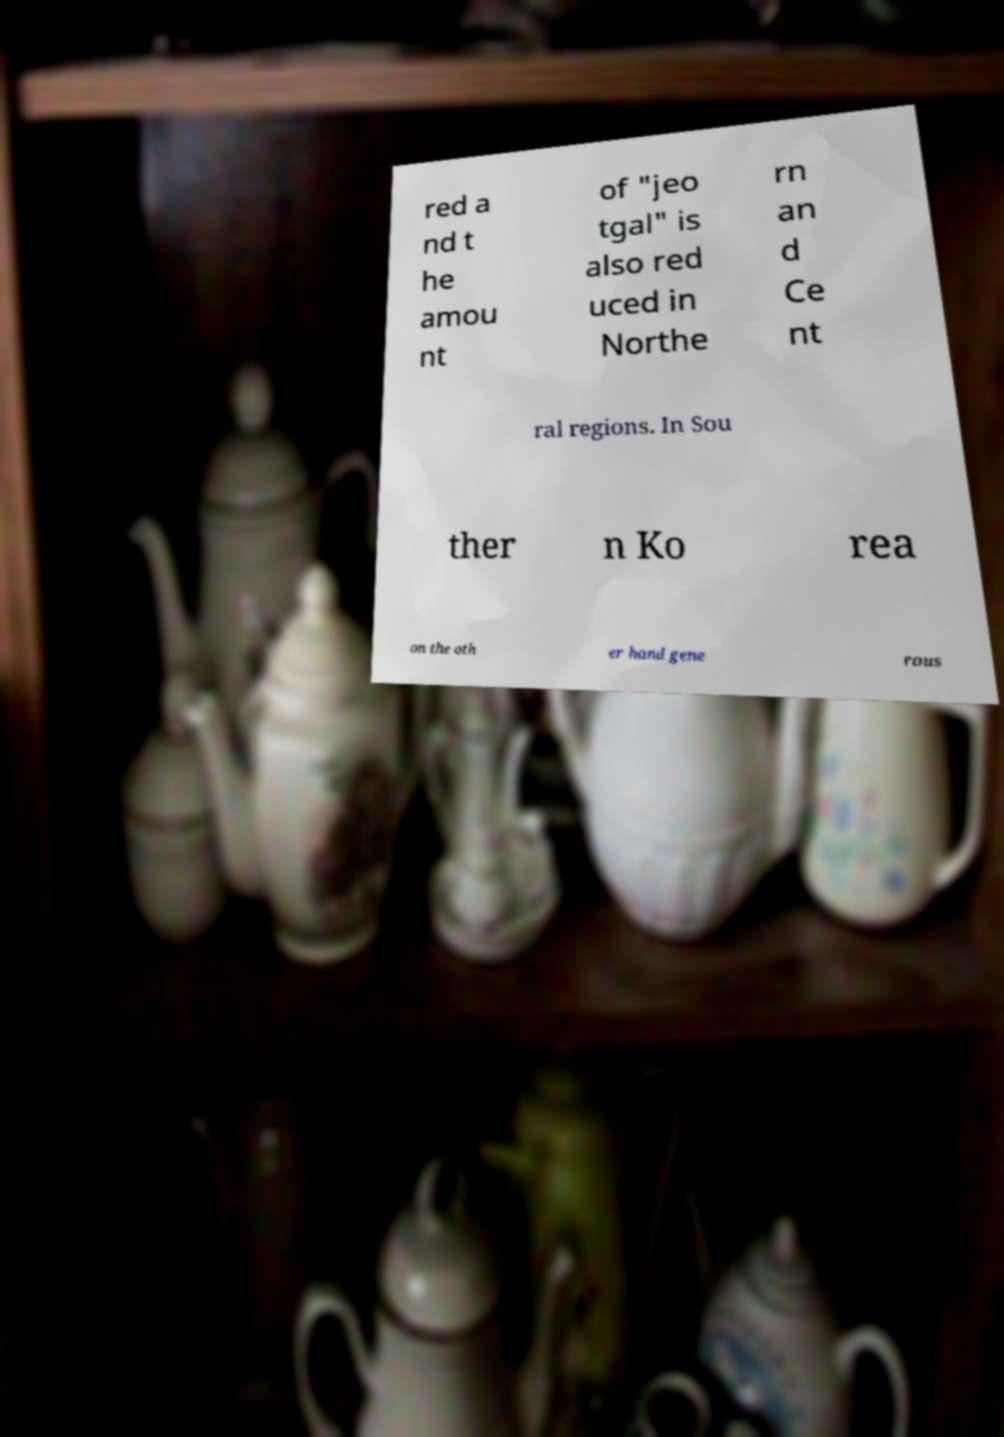For documentation purposes, I need the text within this image transcribed. Could you provide that? red a nd t he amou nt of "jeo tgal" is also red uced in Northe rn an d Ce nt ral regions. In Sou ther n Ko rea on the oth er hand gene rous 